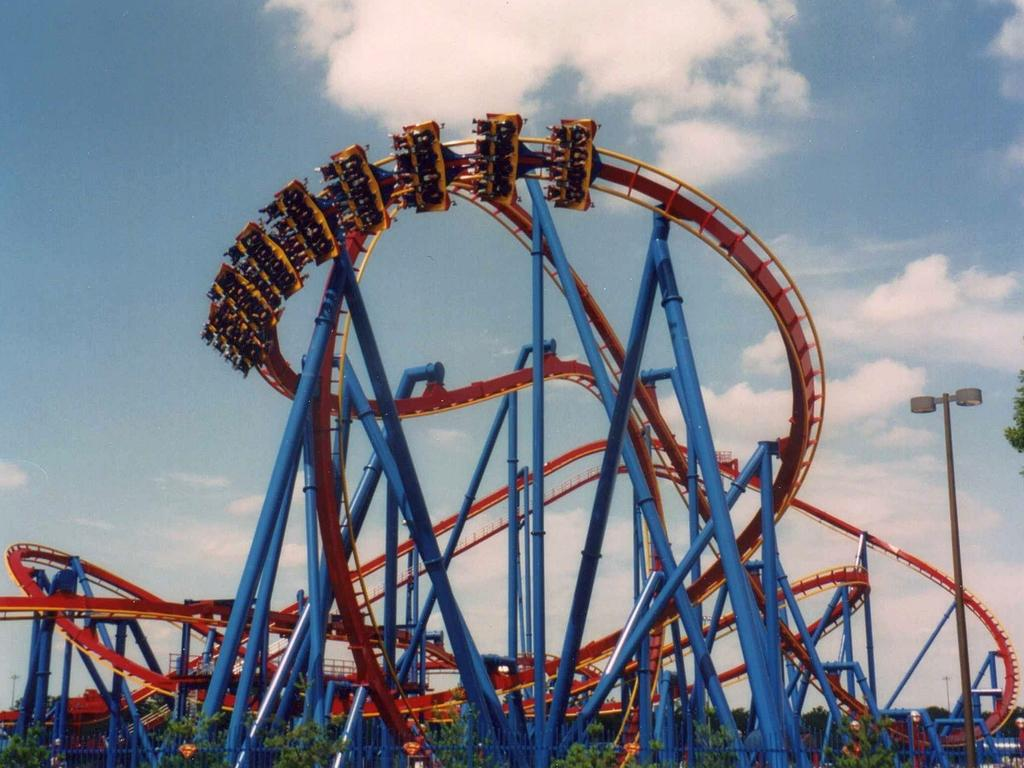What is the main subject of the image? The main subject of the image is a roller coaster. What other elements can be seen in the image? There are trees and the sky visible in the image. What is the condition of the sky in the image? The sky is visible in the background of the image, and clouds are present. What type of company is represented by the roller coaster in the image? The image does not provide any information about a company related to the roller coaster. Can you see a chin on any of the trees in the image? There are no chins present on the trees or any other elements in the image, as chins are a human facial feature and not applicable to inanimate objects or natural elements. 